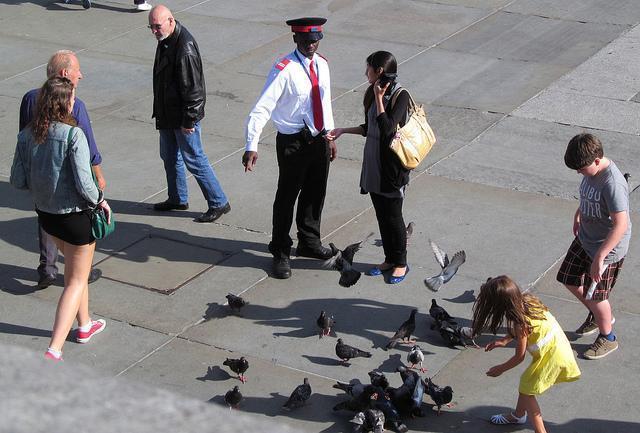How many people can you see?
Give a very brief answer. 7. How many umbrellas are there?
Give a very brief answer. 0. 